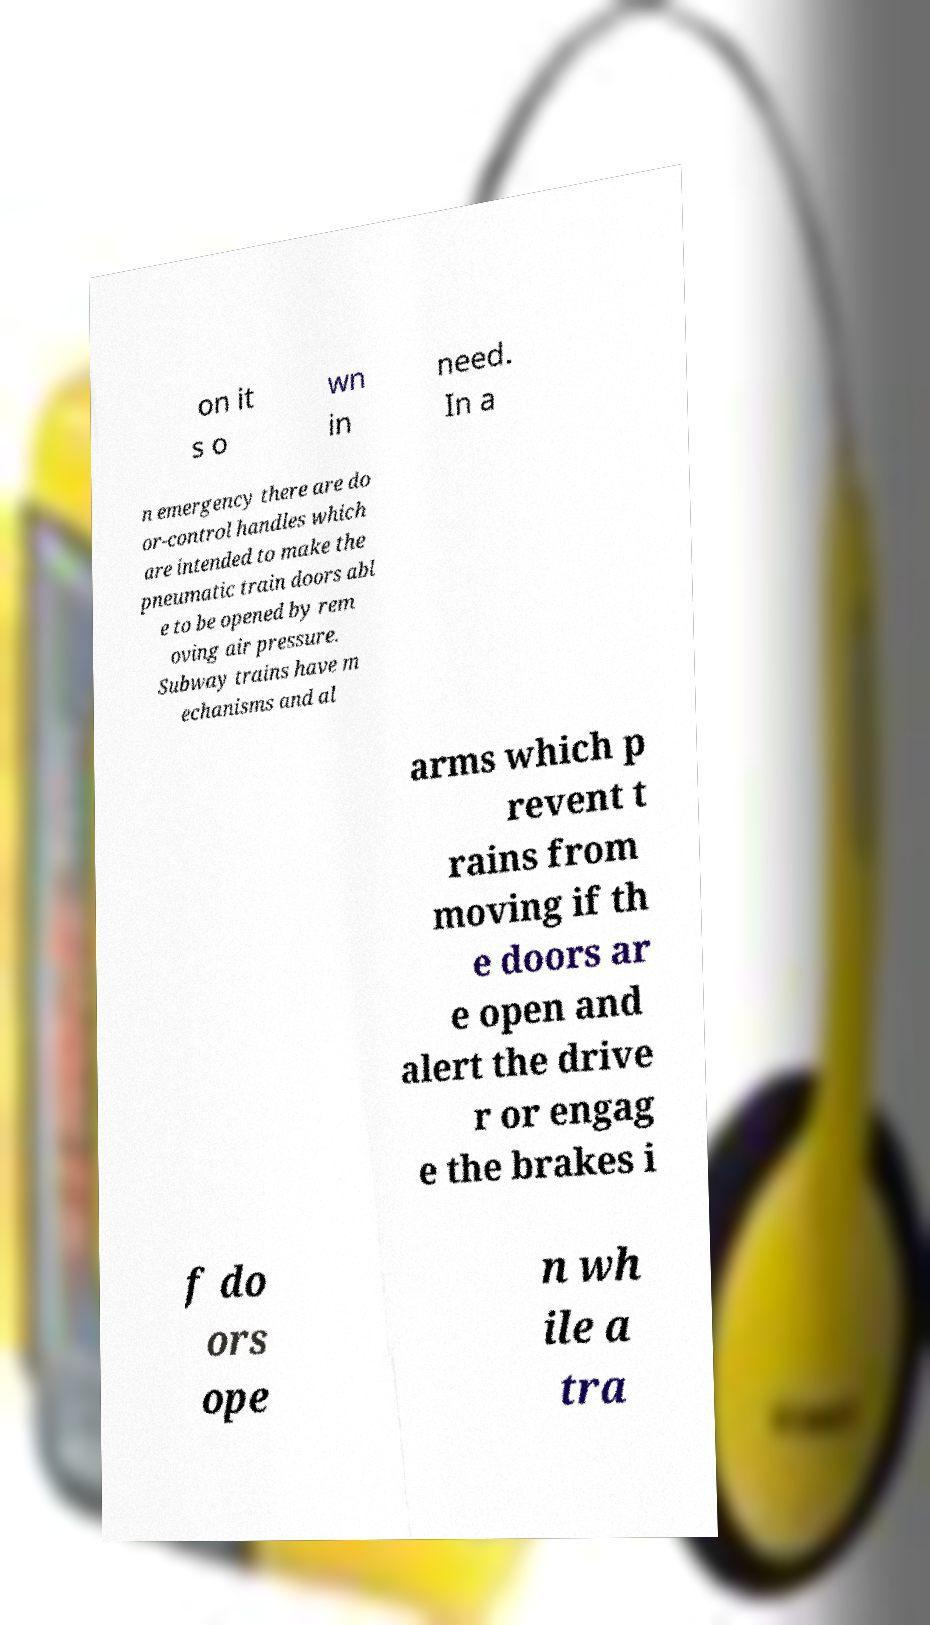Can you accurately transcribe the text from the provided image for me? on it s o wn in need. In a n emergency there are do or-control handles which are intended to make the pneumatic train doors abl e to be opened by rem oving air pressure. Subway trains have m echanisms and al arms which p revent t rains from moving if th e doors ar e open and alert the drive r or engag e the brakes i f do ors ope n wh ile a tra 